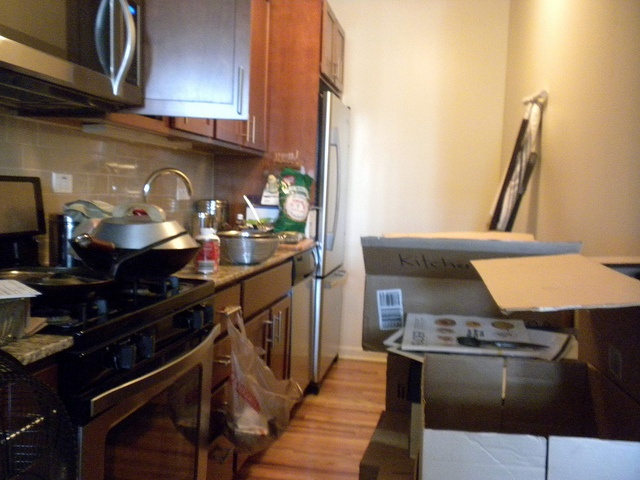Describe the objects in this image and their specific colors. I can see oven in gray, black, and maroon tones, microwave in gray, black, and olive tones, refrigerator in gray, lightgray, and darkgray tones, book in gray and black tones, and bowl in gray, maroon, and darkgray tones in this image. 